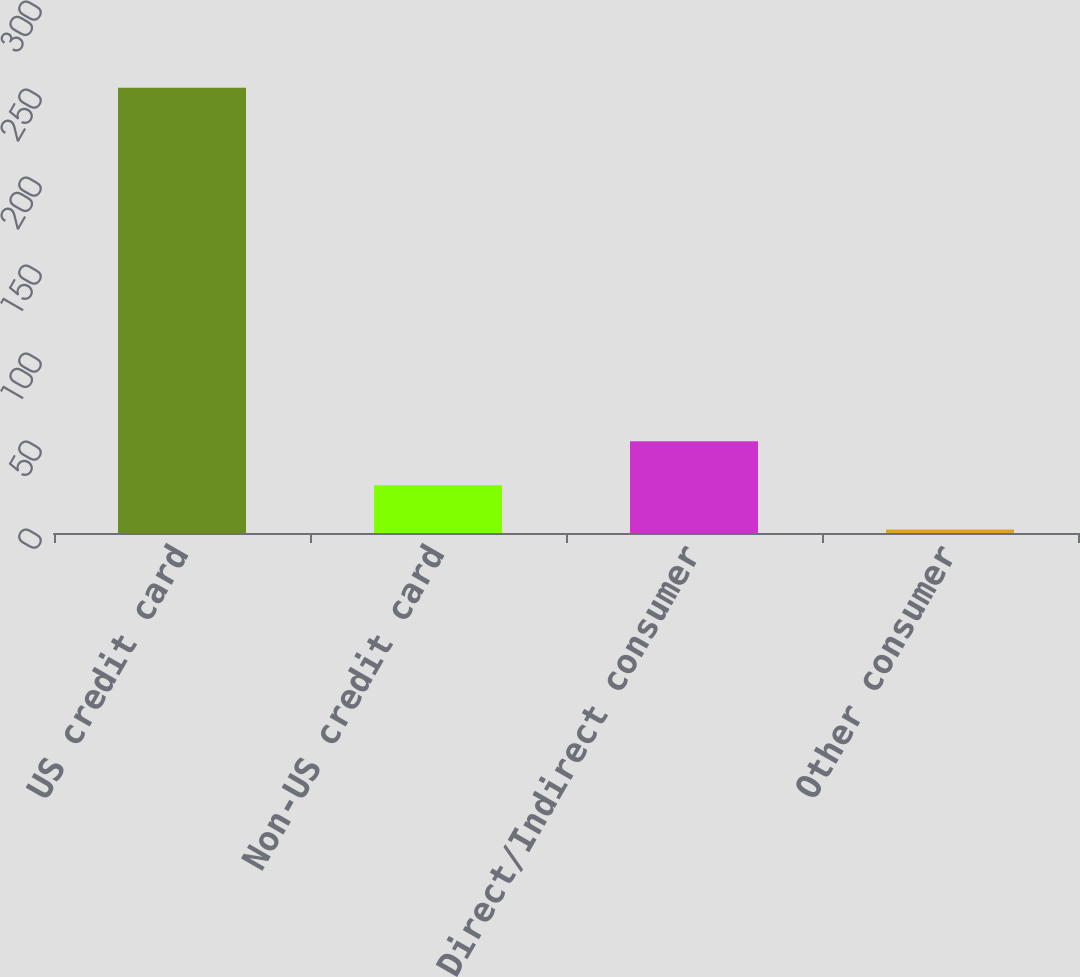<chart> <loc_0><loc_0><loc_500><loc_500><bar_chart><fcel>US credit card<fcel>Non-US credit card<fcel>Direct/Indirect consumer<fcel>Other consumer<nl><fcel>253<fcel>27.1<fcel>52.2<fcel>2<nl></chart> 